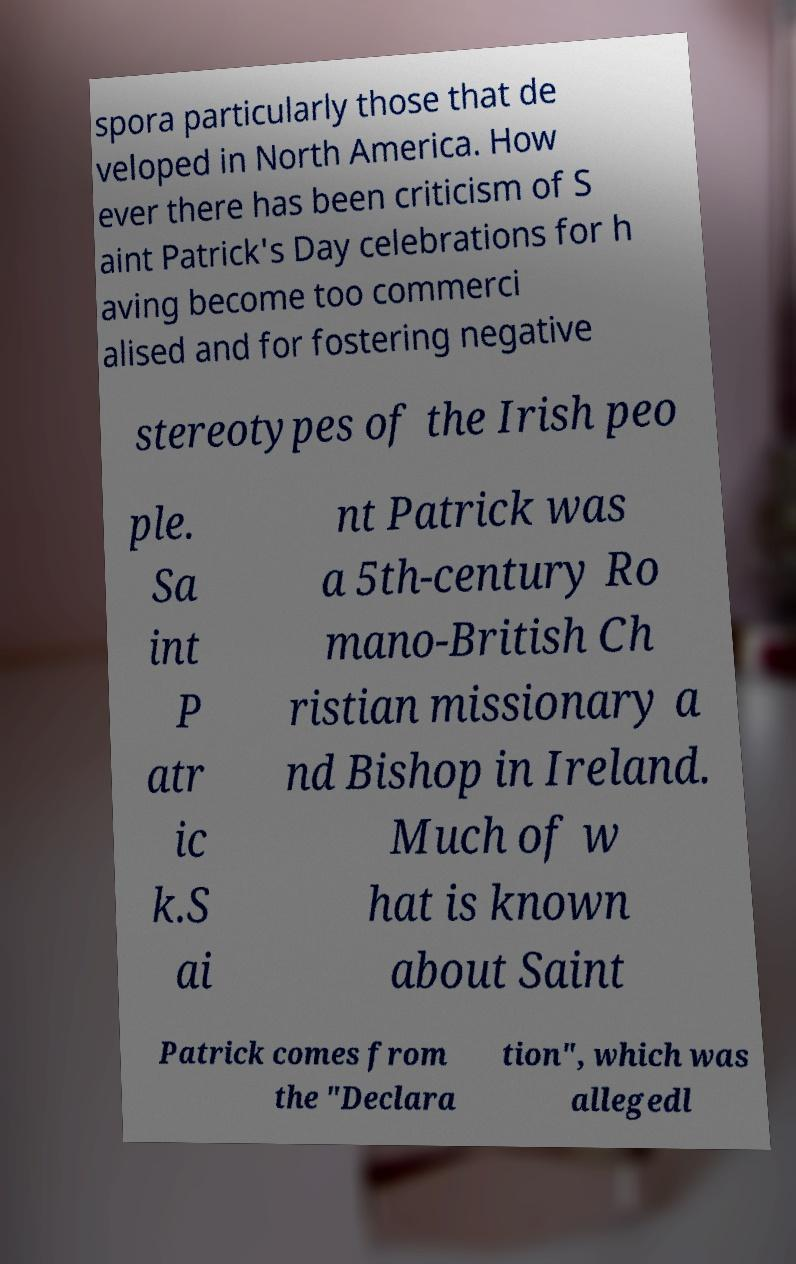Could you extract and type out the text from this image? spora particularly those that de veloped in North America. How ever there has been criticism of S aint Patrick's Day celebrations for h aving become too commerci alised and for fostering negative stereotypes of the Irish peo ple. Sa int P atr ic k.S ai nt Patrick was a 5th-century Ro mano-British Ch ristian missionary a nd Bishop in Ireland. Much of w hat is known about Saint Patrick comes from the "Declara tion", which was allegedl 